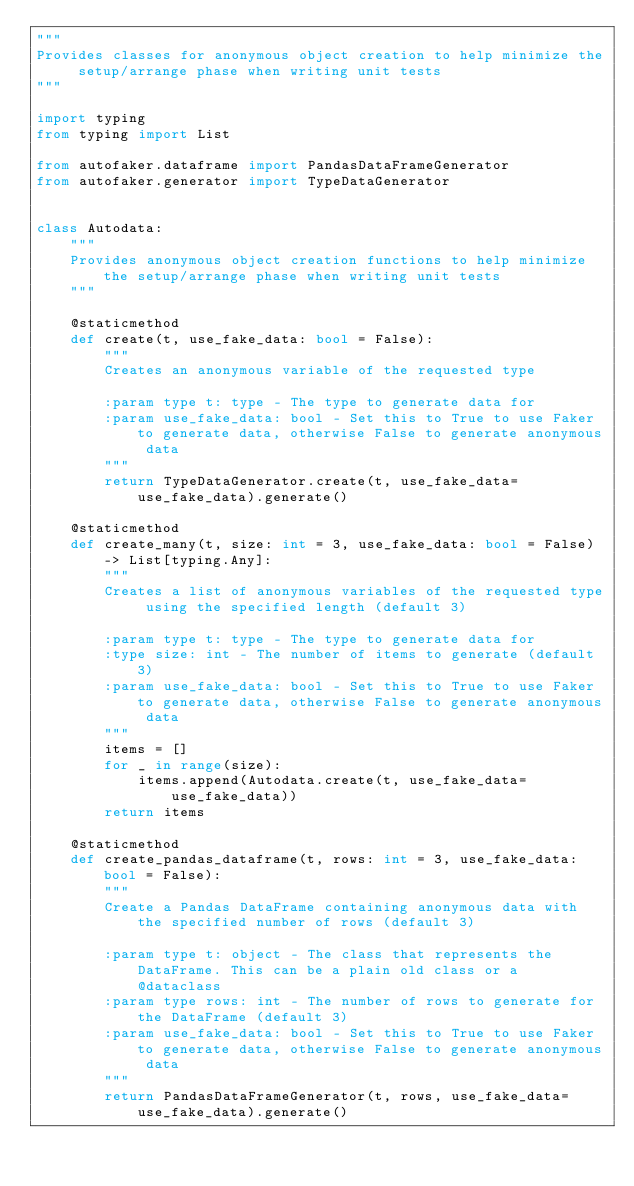Convert code to text. <code><loc_0><loc_0><loc_500><loc_500><_Python_>"""
Provides classes for anonymous object creation to help minimize the setup/arrange phase when writing unit tests
"""

import typing
from typing import List

from autofaker.dataframe import PandasDataFrameGenerator
from autofaker.generator import TypeDataGenerator


class Autodata:
    """
    Provides anonymous object creation functions to help minimize the setup/arrange phase when writing unit tests
    """

    @staticmethod
    def create(t, use_fake_data: bool = False):
        """
        Creates an anonymous variable of the requested type

        :param type t: type - The type to generate data for
        :param use_fake_data: bool - Set this to True to use Faker to generate data, otherwise False to generate anonymous data
        """
        return TypeDataGenerator.create(t, use_fake_data=use_fake_data).generate()

    @staticmethod
    def create_many(t, size: int = 3, use_fake_data: bool = False) -> List[typing.Any]:
        """
        Creates a list of anonymous variables of the requested type using the specified length (default 3)

        :param type t: type - The type to generate data for
        :type size: int - The number of items to generate (default 3)
        :param use_fake_data: bool - Set this to True to use Faker to generate data, otherwise False to generate anonymous data
        """
        items = []
        for _ in range(size):
            items.append(Autodata.create(t, use_fake_data=use_fake_data))
        return items

    @staticmethod
    def create_pandas_dataframe(t, rows: int = 3, use_fake_data: bool = False):
        """
        Create a Pandas DataFrame containing anonymous data with the specified number of rows (default 3)

        :param type t: object - The class that represents the DataFrame. This can be a plain old class or a @dataclass
        :param type rows: int - The number of rows to generate for the DataFrame (default 3)
        :param use_fake_data: bool - Set this to True to use Faker to generate data, otherwise False to generate anonymous data
        """
        return PandasDataFrameGenerator(t, rows, use_fake_data=use_fake_data).generate()
</code> 